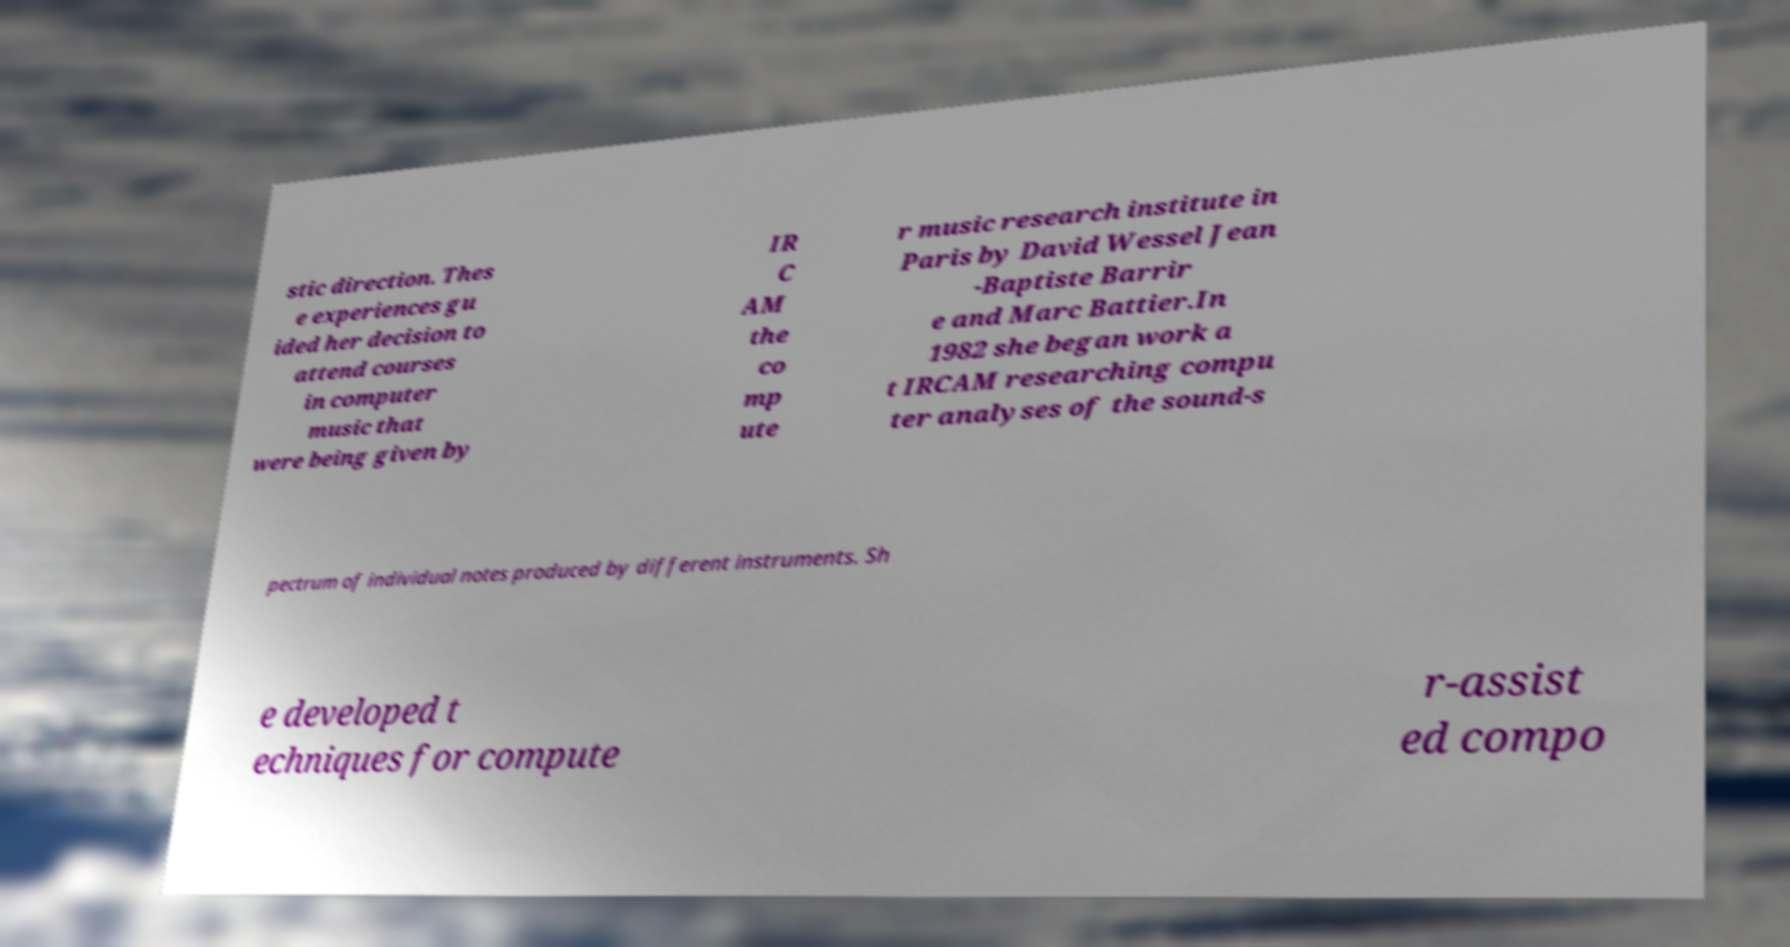There's text embedded in this image that I need extracted. Can you transcribe it verbatim? stic direction. Thes e experiences gu ided her decision to attend courses in computer music that were being given by IR C AM the co mp ute r music research institute in Paris by David Wessel Jean -Baptiste Barrir e and Marc Battier.In 1982 she began work a t IRCAM researching compu ter analyses of the sound-s pectrum of individual notes produced by different instruments. Sh e developed t echniques for compute r-assist ed compo 